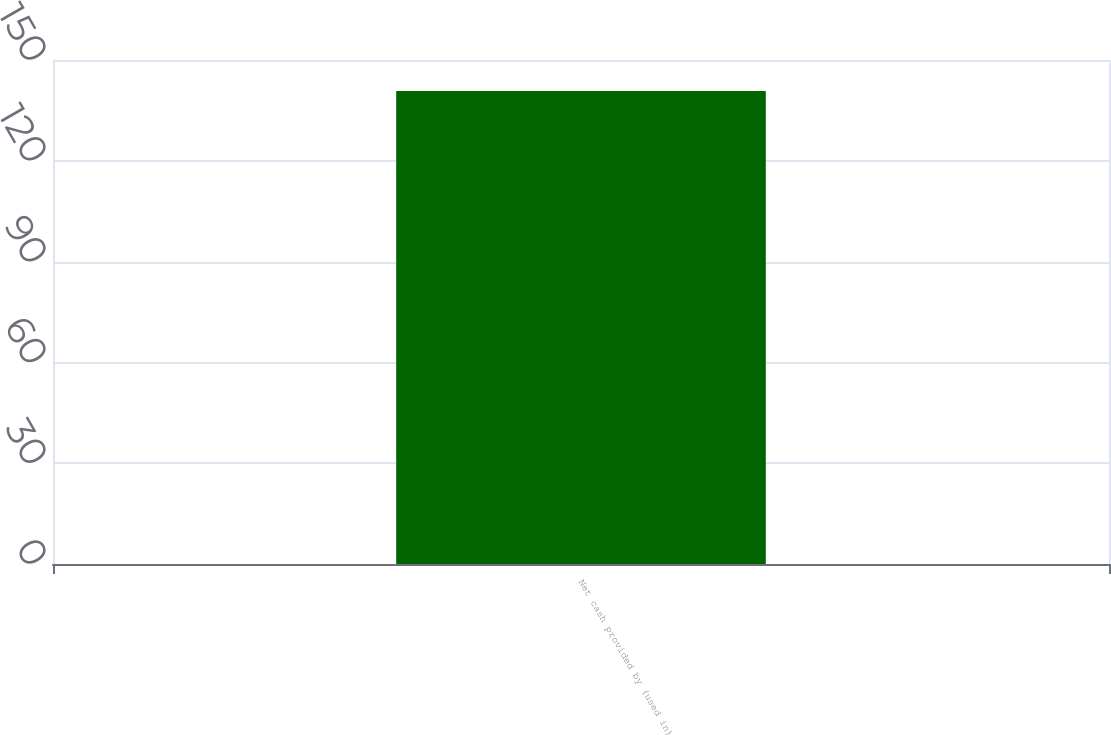Convert chart. <chart><loc_0><loc_0><loc_500><loc_500><bar_chart><fcel>Net cash provided by (used in)<nl><fcel>140.8<nl></chart> 